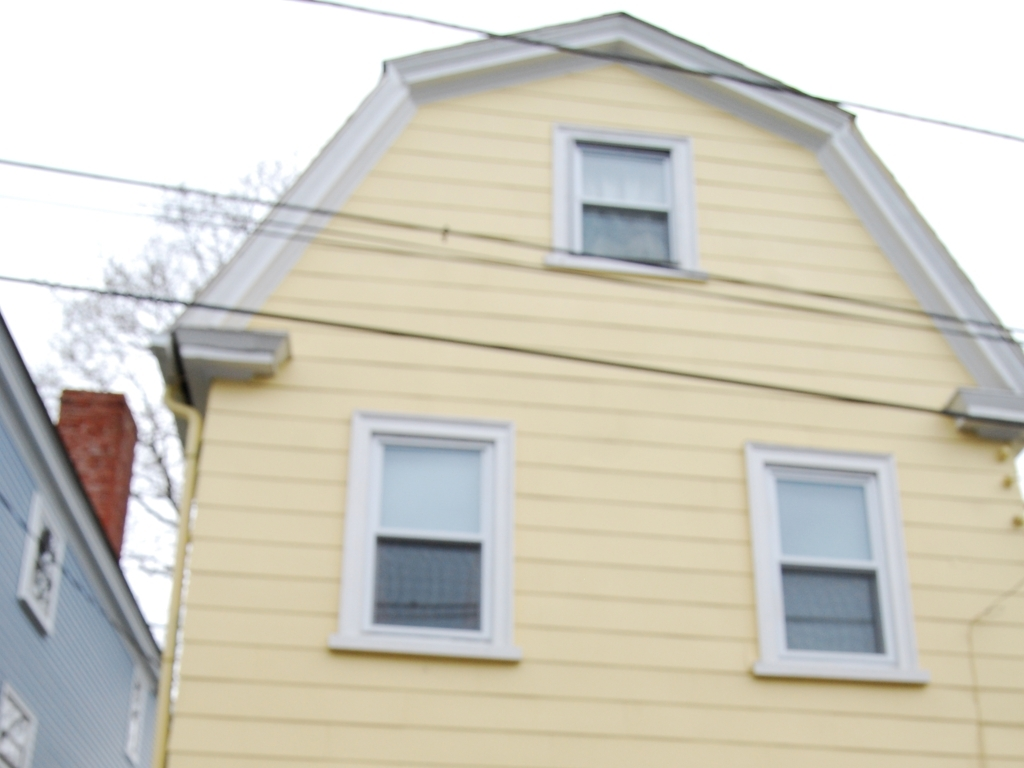What is the weather like in the image? The image suggests overcast weather, as the lighting is diffused and there are no sharp shadows. It appears to be a calm day without much sunlight. 